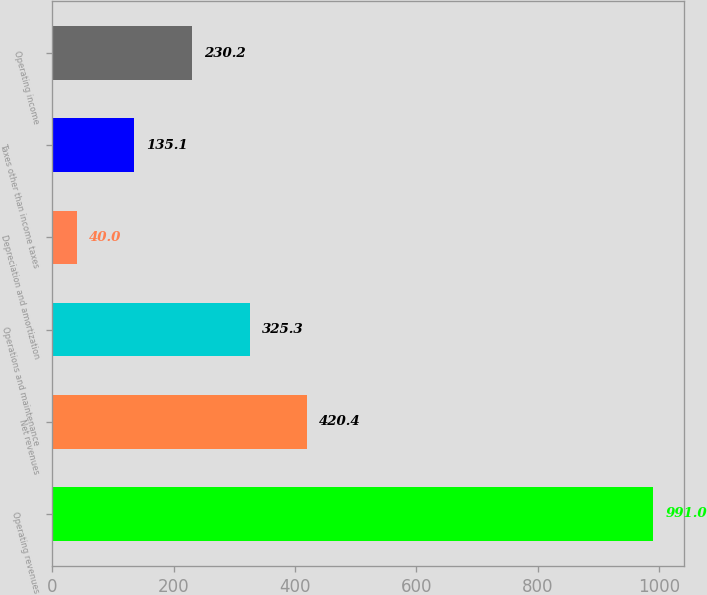<chart> <loc_0><loc_0><loc_500><loc_500><bar_chart><fcel>Operating revenues<fcel>Net revenues<fcel>Operations and maintenance<fcel>Depreciation and amortization<fcel>Taxes other than income taxes<fcel>Operating income<nl><fcel>991<fcel>420.4<fcel>325.3<fcel>40<fcel>135.1<fcel>230.2<nl></chart> 